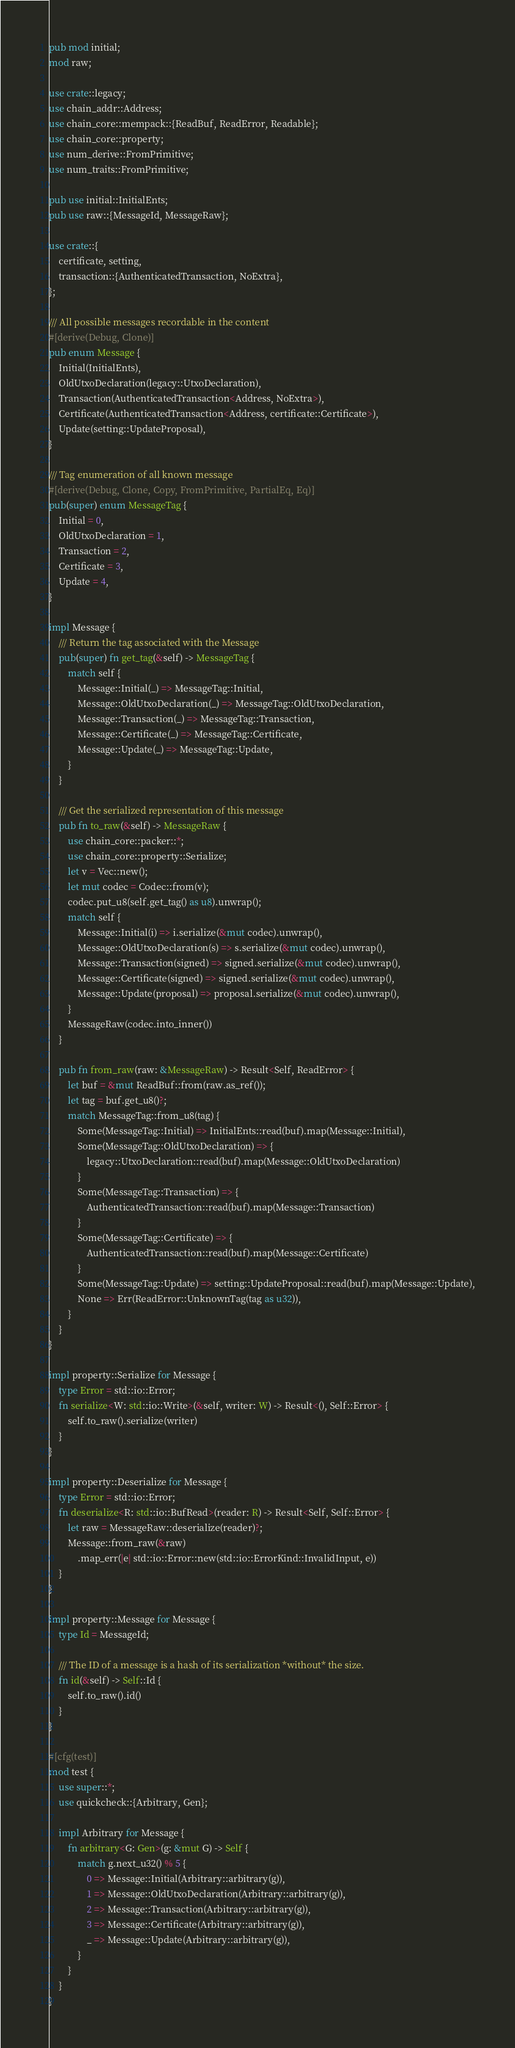Convert code to text. <code><loc_0><loc_0><loc_500><loc_500><_Rust_>pub mod initial;
mod raw;

use crate::legacy;
use chain_addr::Address;
use chain_core::mempack::{ReadBuf, ReadError, Readable};
use chain_core::property;
use num_derive::FromPrimitive;
use num_traits::FromPrimitive;

pub use initial::InitialEnts;
pub use raw::{MessageId, MessageRaw};

use crate::{
    certificate, setting,
    transaction::{AuthenticatedTransaction, NoExtra},
};

/// All possible messages recordable in the content
#[derive(Debug, Clone)]
pub enum Message {
    Initial(InitialEnts),
    OldUtxoDeclaration(legacy::UtxoDeclaration),
    Transaction(AuthenticatedTransaction<Address, NoExtra>),
    Certificate(AuthenticatedTransaction<Address, certificate::Certificate>),
    Update(setting::UpdateProposal),
}

/// Tag enumeration of all known message
#[derive(Debug, Clone, Copy, FromPrimitive, PartialEq, Eq)]
pub(super) enum MessageTag {
    Initial = 0,
    OldUtxoDeclaration = 1,
    Transaction = 2,
    Certificate = 3,
    Update = 4,
}

impl Message {
    /// Return the tag associated with the Message
    pub(super) fn get_tag(&self) -> MessageTag {
        match self {
            Message::Initial(_) => MessageTag::Initial,
            Message::OldUtxoDeclaration(_) => MessageTag::OldUtxoDeclaration,
            Message::Transaction(_) => MessageTag::Transaction,
            Message::Certificate(_) => MessageTag::Certificate,
            Message::Update(_) => MessageTag::Update,
        }
    }

    /// Get the serialized representation of this message
    pub fn to_raw(&self) -> MessageRaw {
        use chain_core::packer::*;
        use chain_core::property::Serialize;
        let v = Vec::new();
        let mut codec = Codec::from(v);
        codec.put_u8(self.get_tag() as u8).unwrap();
        match self {
            Message::Initial(i) => i.serialize(&mut codec).unwrap(),
            Message::OldUtxoDeclaration(s) => s.serialize(&mut codec).unwrap(),
            Message::Transaction(signed) => signed.serialize(&mut codec).unwrap(),
            Message::Certificate(signed) => signed.serialize(&mut codec).unwrap(),
            Message::Update(proposal) => proposal.serialize(&mut codec).unwrap(),
        }
        MessageRaw(codec.into_inner())
    }

    pub fn from_raw(raw: &MessageRaw) -> Result<Self, ReadError> {
        let buf = &mut ReadBuf::from(raw.as_ref());
        let tag = buf.get_u8()?;
        match MessageTag::from_u8(tag) {
            Some(MessageTag::Initial) => InitialEnts::read(buf).map(Message::Initial),
            Some(MessageTag::OldUtxoDeclaration) => {
                legacy::UtxoDeclaration::read(buf).map(Message::OldUtxoDeclaration)
            }
            Some(MessageTag::Transaction) => {
                AuthenticatedTransaction::read(buf).map(Message::Transaction)
            }
            Some(MessageTag::Certificate) => {
                AuthenticatedTransaction::read(buf).map(Message::Certificate)
            }
            Some(MessageTag::Update) => setting::UpdateProposal::read(buf).map(Message::Update),
            None => Err(ReadError::UnknownTag(tag as u32)),
        }
    }
}

impl property::Serialize for Message {
    type Error = std::io::Error;
    fn serialize<W: std::io::Write>(&self, writer: W) -> Result<(), Self::Error> {
        self.to_raw().serialize(writer)
    }
}

impl property::Deserialize for Message {
    type Error = std::io::Error;
    fn deserialize<R: std::io::BufRead>(reader: R) -> Result<Self, Self::Error> {
        let raw = MessageRaw::deserialize(reader)?;
        Message::from_raw(&raw)
            .map_err(|e| std::io::Error::new(std::io::ErrorKind::InvalidInput, e))
    }
}

impl property::Message for Message {
    type Id = MessageId;

    /// The ID of a message is a hash of its serialization *without* the size.
    fn id(&self) -> Self::Id {
        self.to_raw().id()
    }
}

#[cfg(test)]
mod test {
    use super::*;
    use quickcheck::{Arbitrary, Gen};

    impl Arbitrary for Message {
        fn arbitrary<G: Gen>(g: &mut G) -> Self {
            match g.next_u32() % 5 {
                0 => Message::Initial(Arbitrary::arbitrary(g)),
                1 => Message::OldUtxoDeclaration(Arbitrary::arbitrary(g)),
                2 => Message::Transaction(Arbitrary::arbitrary(g)),
                3 => Message::Certificate(Arbitrary::arbitrary(g)),
                _ => Message::Update(Arbitrary::arbitrary(g)),
            }
        }
    }
}
</code> 